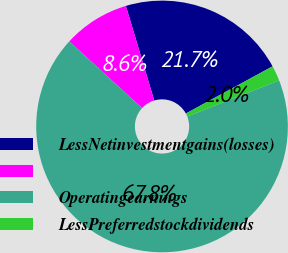<chart> <loc_0><loc_0><loc_500><loc_500><pie_chart><fcel>LessNetinvestmentgains(losses)<fcel>Unnamed: 1<fcel>Operatingearnings<fcel>LessPreferredstockdividends<nl><fcel>21.71%<fcel>8.55%<fcel>67.77%<fcel>1.97%<nl></chart> 